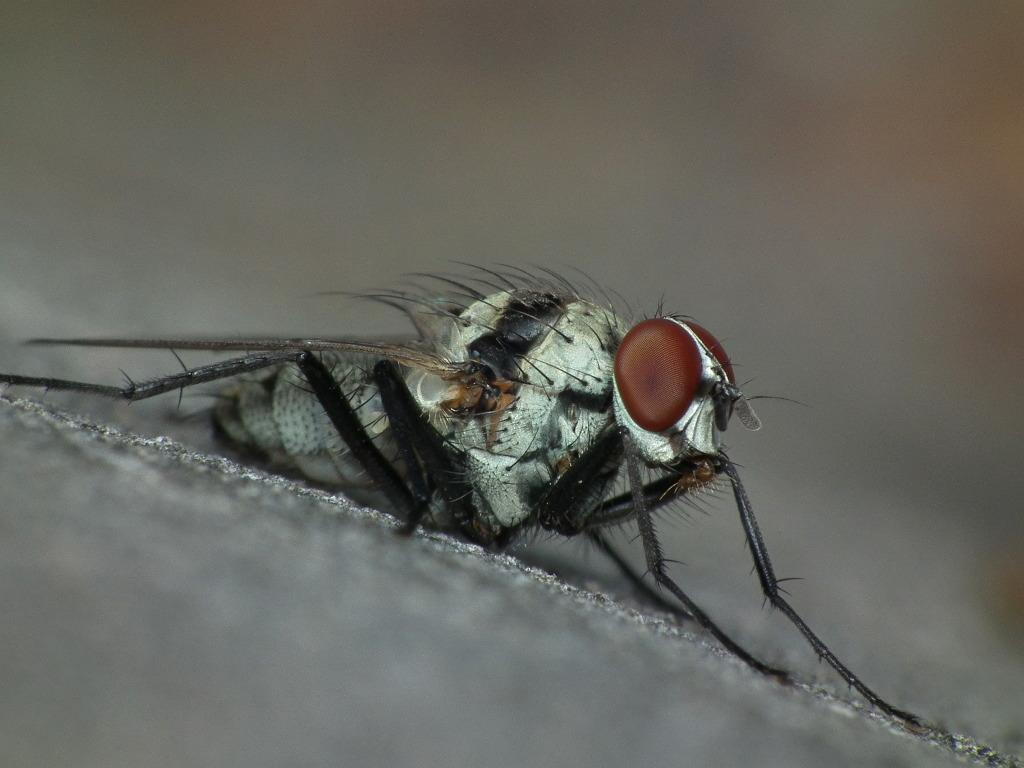What is the main subject of the image? There is a housefly in the center of the image. What type of operation is being performed on the housefly in the image? There is no operation being performed on the housefly in the image; it is simply a housefly in the center of the image. 